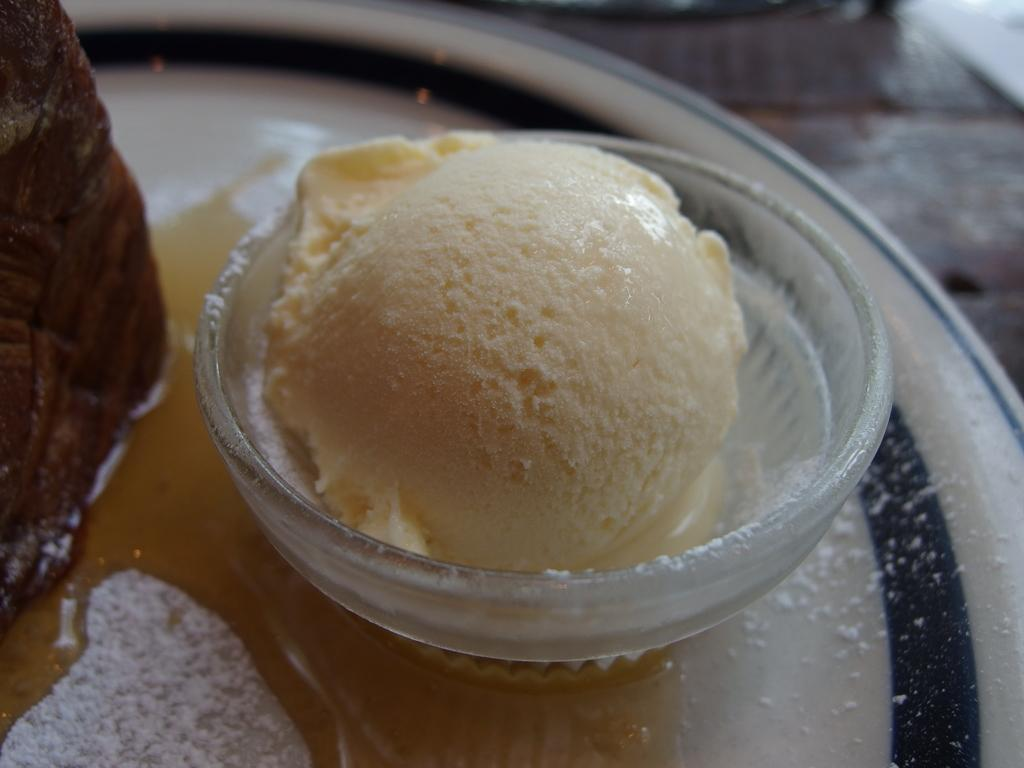What is in the bowl that is visible in the image? There is an ice cream in the bowl in the image. What is in the plate that is visible in the image? There is a food item and powder in the plate in the image, along with other objects. What can be seen in the background of the image? There is a wooden texture in the background of the image. How does the ice cream watch the operation in the image? The ice cream does not watch any operation in the image; it is a stationary food item in the bowl. 